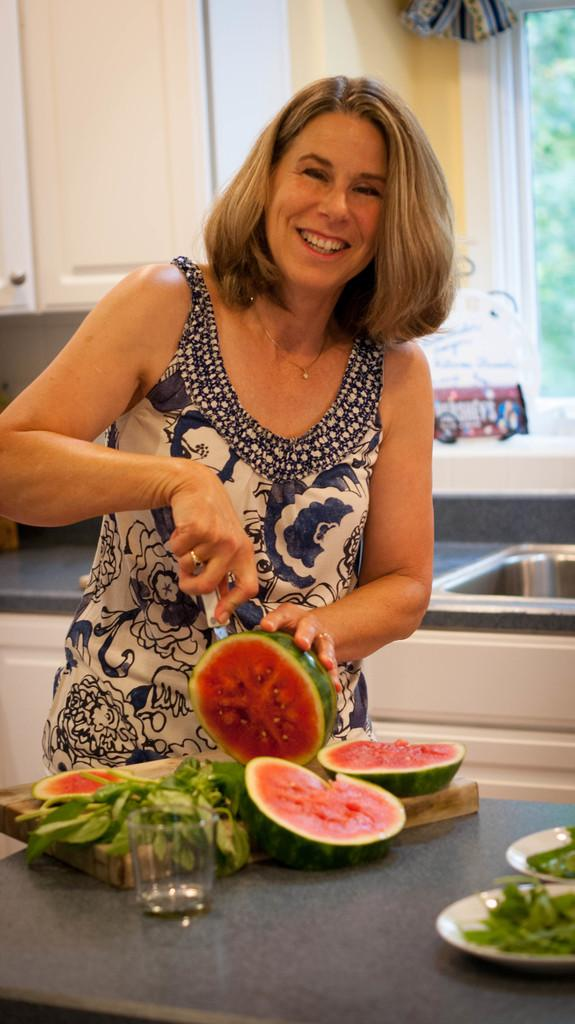Who is the main subject in the image? There is a woman in the image. What is a noticeable feature of the woman? The woman has golden hair. What activity is the woman engaged in? The woman is cutting a watermelon. Where is the cutting taking place? The cutting is taking place on a table. What other items can be seen on the table? There is a glass and plates on the table. What is located behind the woman? There are cupboards and a washbasin behind the woman. Where can the woman be seen selling fruits in the image? There is no indication in the image that the woman is selling fruits or at a market. What type of guitar is the woman playing in the image? There is no guitar present in the image. 